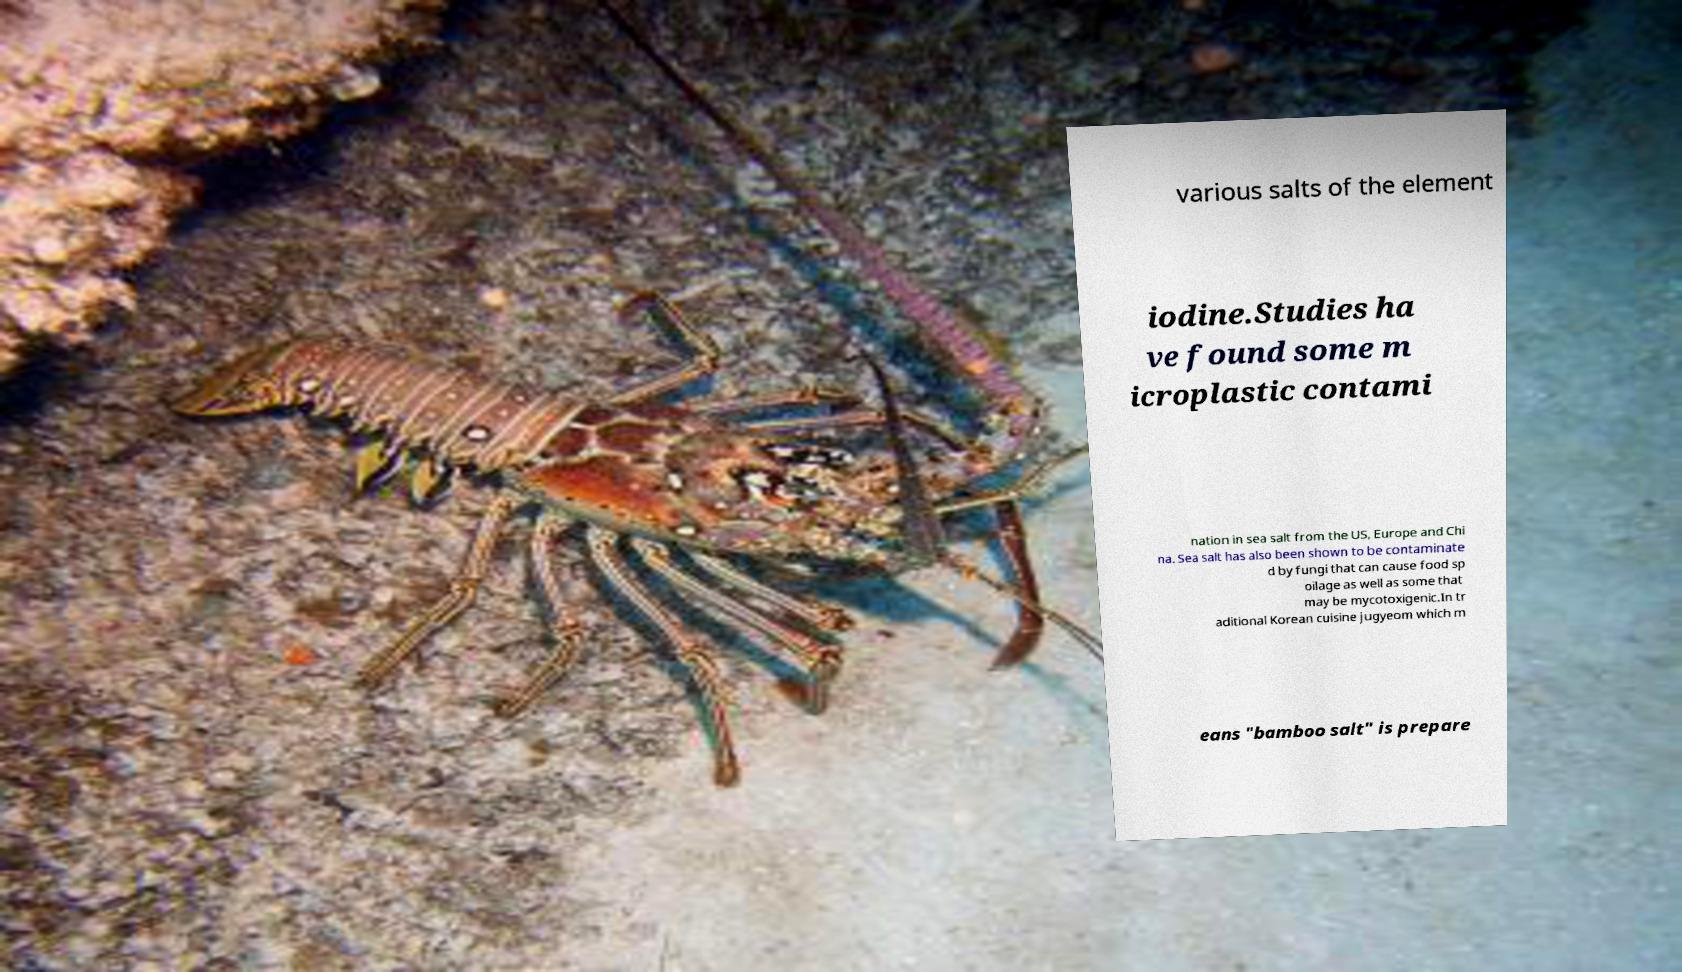There's text embedded in this image that I need extracted. Can you transcribe it verbatim? various salts of the element iodine.Studies ha ve found some m icroplastic contami nation in sea salt from the US, Europe and Chi na. Sea salt has also been shown to be contaminate d by fungi that can cause food sp oilage as well as some that may be mycotoxigenic.In tr aditional Korean cuisine jugyeom which m eans "bamboo salt" is prepare 